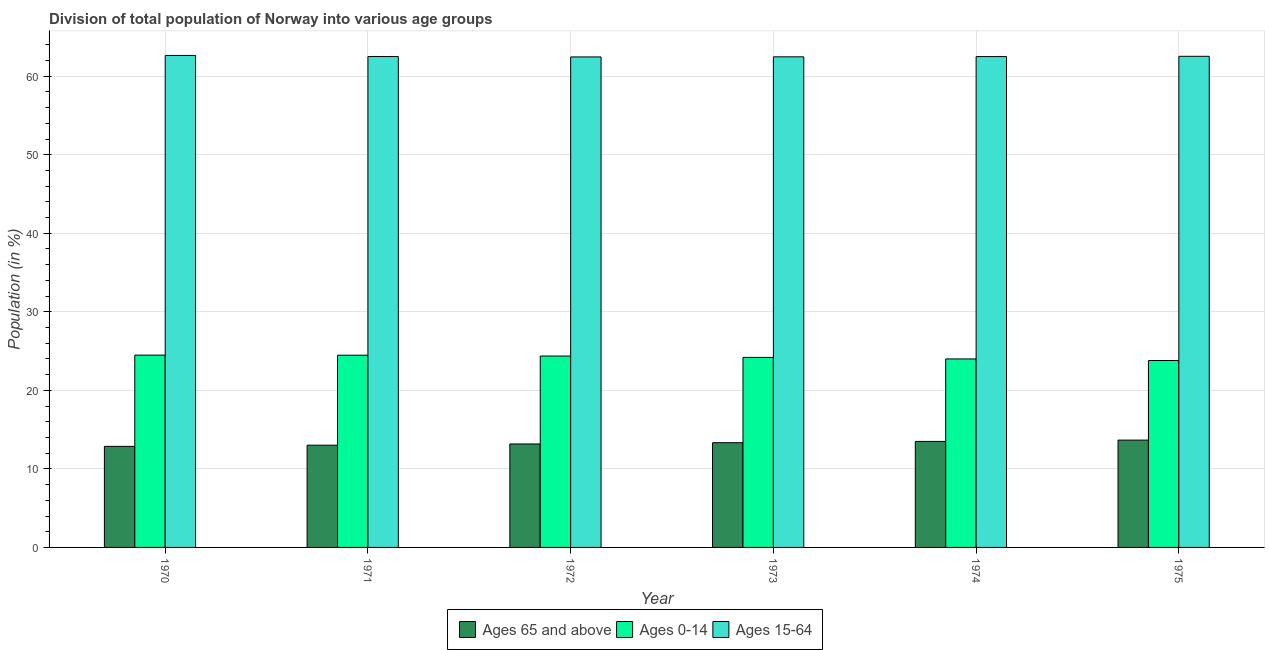How many different coloured bars are there?
Your response must be concise. 3. How many groups of bars are there?
Your answer should be compact. 6. How many bars are there on the 6th tick from the right?
Provide a succinct answer. 3. What is the label of the 6th group of bars from the left?
Provide a succinct answer. 1975. What is the percentage of population within the age-group 15-64 in 1971?
Your answer should be compact. 62.5. Across all years, what is the maximum percentage of population within the age-group 15-64?
Provide a short and direct response. 62.65. Across all years, what is the minimum percentage of population within the age-group 15-64?
Provide a succinct answer. 62.46. In which year was the percentage of population within the age-group 0-14 maximum?
Your response must be concise. 1970. In which year was the percentage of population within the age-group 15-64 minimum?
Provide a succinct answer. 1972. What is the total percentage of population within the age-group 15-64 in the graph?
Provide a succinct answer. 375.11. What is the difference between the percentage of population within the age-group 0-14 in 1974 and that in 1975?
Offer a very short reply. 0.2. What is the difference between the percentage of population within the age-group of 65 and above in 1970 and the percentage of population within the age-group 15-64 in 1971?
Offer a terse response. -0.15. What is the average percentage of population within the age-group 15-64 per year?
Offer a very short reply. 62.52. In the year 1974, what is the difference between the percentage of population within the age-group of 65 and above and percentage of population within the age-group 0-14?
Your answer should be compact. 0. In how many years, is the percentage of population within the age-group 15-64 greater than 20 %?
Provide a succinct answer. 6. What is the ratio of the percentage of population within the age-group 15-64 in 1970 to that in 1972?
Offer a terse response. 1. What is the difference between the highest and the second highest percentage of population within the age-group 0-14?
Provide a short and direct response. 0.01. What is the difference between the highest and the lowest percentage of population within the age-group 15-64?
Ensure brevity in your answer.  0.19. In how many years, is the percentage of population within the age-group of 65 and above greater than the average percentage of population within the age-group of 65 and above taken over all years?
Offer a very short reply. 3. What does the 2nd bar from the left in 1970 represents?
Your answer should be compact. Ages 0-14. What does the 2nd bar from the right in 1975 represents?
Give a very brief answer. Ages 0-14. Is it the case that in every year, the sum of the percentage of population within the age-group of 65 and above and percentage of population within the age-group 0-14 is greater than the percentage of population within the age-group 15-64?
Your response must be concise. No. How many bars are there?
Ensure brevity in your answer.  18. Are all the bars in the graph horizontal?
Provide a short and direct response. No. How many legend labels are there?
Make the answer very short. 3. How are the legend labels stacked?
Give a very brief answer. Horizontal. What is the title of the graph?
Offer a very short reply. Division of total population of Norway into various age groups
. What is the label or title of the X-axis?
Your response must be concise. Year. What is the Population (in %) of Ages 65 and above in 1970?
Give a very brief answer. 12.87. What is the Population (in %) of Ages 0-14 in 1970?
Ensure brevity in your answer.  24.49. What is the Population (in %) in Ages 15-64 in 1970?
Your response must be concise. 62.65. What is the Population (in %) of Ages 65 and above in 1971?
Keep it short and to the point. 13.02. What is the Population (in %) of Ages 0-14 in 1971?
Make the answer very short. 24.48. What is the Population (in %) of Ages 15-64 in 1971?
Give a very brief answer. 62.5. What is the Population (in %) in Ages 65 and above in 1972?
Keep it short and to the point. 13.17. What is the Population (in %) in Ages 0-14 in 1972?
Offer a terse response. 24.37. What is the Population (in %) of Ages 15-64 in 1972?
Provide a short and direct response. 62.46. What is the Population (in %) in Ages 65 and above in 1973?
Give a very brief answer. 13.34. What is the Population (in %) of Ages 0-14 in 1973?
Provide a short and direct response. 24.2. What is the Population (in %) in Ages 15-64 in 1973?
Your response must be concise. 62.47. What is the Population (in %) of Ages 65 and above in 1974?
Provide a short and direct response. 13.5. What is the Population (in %) of Ages 0-14 in 1974?
Provide a short and direct response. 24. What is the Population (in %) of Ages 15-64 in 1974?
Provide a succinct answer. 62.5. What is the Population (in %) in Ages 65 and above in 1975?
Make the answer very short. 13.67. What is the Population (in %) in Ages 0-14 in 1975?
Your answer should be very brief. 23.8. What is the Population (in %) in Ages 15-64 in 1975?
Ensure brevity in your answer.  62.53. Across all years, what is the maximum Population (in %) in Ages 65 and above?
Your answer should be compact. 13.67. Across all years, what is the maximum Population (in %) in Ages 0-14?
Give a very brief answer. 24.49. Across all years, what is the maximum Population (in %) in Ages 15-64?
Ensure brevity in your answer.  62.65. Across all years, what is the minimum Population (in %) in Ages 65 and above?
Ensure brevity in your answer.  12.87. Across all years, what is the minimum Population (in %) of Ages 0-14?
Give a very brief answer. 23.8. Across all years, what is the minimum Population (in %) of Ages 15-64?
Ensure brevity in your answer.  62.46. What is the total Population (in %) of Ages 65 and above in the graph?
Offer a very short reply. 79.56. What is the total Population (in %) of Ages 0-14 in the graph?
Offer a very short reply. 145.33. What is the total Population (in %) of Ages 15-64 in the graph?
Provide a short and direct response. 375.11. What is the difference between the Population (in %) in Ages 65 and above in 1970 and that in 1971?
Offer a terse response. -0.15. What is the difference between the Population (in %) of Ages 0-14 in 1970 and that in 1971?
Ensure brevity in your answer.  0.01. What is the difference between the Population (in %) of Ages 15-64 in 1970 and that in 1971?
Give a very brief answer. 0.14. What is the difference between the Population (in %) in Ages 65 and above in 1970 and that in 1972?
Make the answer very short. -0.31. What is the difference between the Population (in %) in Ages 0-14 in 1970 and that in 1972?
Offer a terse response. 0.12. What is the difference between the Population (in %) in Ages 15-64 in 1970 and that in 1972?
Your answer should be very brief. 0.19. What is the difference between the Population (in %) of Ages 65 and above in 1970 and that in 1973?
Provide a short and direct response. -0.47. What is the difference between the Population (in %) of Ages 0-14 in 1970 and that in 1973?
Keep it short and to the point. 0.29. What is the difference between the Population (in %) in Ages 15-64 in 1970 and that in 1973?
Give a very brief answer. 0.18. What is the difference between the Population (in %) of Ages 65 and above in 1970 and that in 1974?
Your answer should be compact. -0.63. What is the difference between the Population (in %) in Ages 0-14 in 1970 and that in 1974?
Your answer should be very brief. 0.48. What is the difference between the Population (in %) in Ages 15-64 in 1970 and that in 1974?
Provide a succinct answer. 0.15. What is the difference between the Population (in %) in Ages 65 and above in 1970 and that in 1975?
Give a very brief answer. -0.8. What is the difference between the Population (in %) of Ages 0-14 in 1970 and that in 1975?
Your answer should be compact. 0.69. What is the difference between the Population (in %) in Ages 15-64 in 1970 and that in 1975?
Provide a succinct answer. 0.11. What is the difference between the Population (in %) in Ages 65 and above in 1971 and that in 1972?
Offer a very short reply. -0.16. What is the difference between the Population (in %) of Ages 0-14 in 1971 and that in 1972?
Provide a short and direct response. 0.11. What is the difference between the Population (in %) of Ages 15-64 in 1971 and that in 1972?
Your answer should be compact. 0.05. What is the difference between the Population (in %) of Ages 65 and above in 1971 and that in 1973?
Offer a very short reply. -0.32. What is the difference between the Population (in %) in Ages 0-14 in 1971 and that in 1973?
Ensure brevity in your answer.  0.28. What is the difference between the Population (in %) of Ages 15-64 in 1971 and that in 1973?
Offer a very short reply. 0.04. What is the difference between the Population (in %) in Ages 65 and above in 1971 and that in 1974?
Provide a succinct answer. -0.48. What is the difference between the Population (in %) of Ages 0-14 in 1971 and that in 1974?
Your answer should be compact. 0.47. What is the difference between the Population (in %) in Ages 15-64 in 1971 and that in 1974?
Offer a very short reply. 0. What is the difference between the Population (in %) in Ages 65 and above in 1971 and that in 1975?
Offer a terse response. -0.65. What is the difference between the Population (in %) of Ages 0-14 in 1971 and that in 1975?
Your answer should be very brief. 0.68. What is the difference between the Population (in %) of Ages 15-64 in 1971 and that in 1975?
Keep it short and to the point. -0.03. What is the difference between the Population (in %) of Ages 65 and above in 1972 and that in 1973?
Ensure brevity in your answer.  -0.16. What is the difference between the Population (in %) of Ages 0-14 in 1972 and that in 1973?
Make the answer very short. 0.17. What is the difference between the Population (in %) in Ages 15-64 in 1972 and that in 1973?
Provide a succinct answer. -0.01. What is the difference between the Population (in %) of Ages 65 and above in 1972 and that in 1974?
Ensure brevity in your answer.  -0.32. What is the difference between the Population (in %) in Ages 0-14 in 1972 and that in 1974?
Make the answer very short. 0.37. What is the difference between the Population (in %) in Ages 15-64 in 1972 and that in 1974?
Ensure brevity in your answer.  -0.04. What is the difference between the Population (in %) of Ages 65 and above in 1972 and that in 1975?
Offer a very short reply. -0.49. What is the difference between the Population (in %) of Ages 0-14 in 1972 and that in 1975?
Provide a short and direct response. 0.57. What is the difference between the Population (in %) of Ages 15-64 in 1972 and that in 1975?
Provide a short and direct response. -0.08. What is the difference between the Population (in %) in Ages 65 and above in 1973 and that in 1974?
Provide a succinct answer. -0.16. What is the difference between the Population (in %) of Ages 0-14 in 1973 and that in 1974?
Give a very brief answer. 0.19. What is the difference between the Population (in %) in Ages 15-64 in 1973 and that in 1974?
Ensure brevity in your answer.  -0.03. What is the difference between the Population (in %) in Ages 65 and above in 1973 and that in 1975?
Give a very brief answer. -0.33. What is the difference between the Population (in %) in Ages 0-14 in 1973 and that in 1975?
Give a very brief answer. 0.4. What is the difference between the Population (in %) in Ages 15-64 in 1973 and that in 1975?
Keep it short and to the point. -0.07. What is the difference between the Population (in %) in Ages 65 and above in 1974 and that in 1975?
Your response must be concise. -0.17. What is the difference between the Population (in %) of Ages 0-14 in 1974 and that in 1975?
Make the answer very short. 0.2. What is the difference between the Population (in %) in Ages 15-64 in 1974 and that in 1975?
Your answer should be compact. -0.04. What is the difference between the Population (in %) in Ages 65 and above in 1970 and the Population (in %) in Ages 0-14 in 1971?
Your answer should be very brief. -11.61. What is the difference between the Population (in %) of Ages 65 and above in 1970 and the Population (in %) of Ages 15-64 in 1971?
Provide a succinct answer. -49.64. What is the difference between the Population (in %) of Ages 0-14 in 1970 and the Population (in %) of Ages 15-64 in 1971?
Ensure brevity in your answer.  -38.02. What is the difference between the Population (in %) of Ages 65 and above in 1970 and the Population (in %) of Ages 0-14 in 1972?
Your answer should be compact. -11.5. What is the difference between the Population (in %) in Ages 65 and above in 1970 and the Population (in %) in Ages 15-64 in 1972?
Offer a very short reply. -49.59. What is the difference between the Population (in %) in Ages 0-14 in 1970 and the Population (in %) in Ages 15-64 in 1972?
Give a very brief answer. -37.97. What is the difference between the Population (in %) in Ages 65 and above in 1970 and the Population (in %) in Ages 0-14 in 1973?
Your answer should be compact. -11.33. What is the difference between the Population (in %) in Ages 65 and above in 1970 and the Population (in %) in Ages 15-64 in 1973?
Your answer should be very brief. -49.6. What is the difference between the Population (in %) of Ages 0-14 in 1970 and the Population (in %) of Ages 15-64 in 1973?
Make the answer very short. -37.98. What is the difference between the Population (in %) of Ages 65 and above in 1970 and the Population (in %) of Ages 0-14 in 1974?
Offer a very short reply. -11.13. What is the difference between the Population (in %) in Ages 65 and above in 1970 and the Population (in %) in Ages 15-64 in 1974?
Provide a short and direct response. -49.63. What is the difference between the Population (in %) of Ages 0-14 in 1970 and the Population (in %) of Ages 15-64 in 1974?
Make the answer very short. -38.01. What is the difference between the Population (in %) of Ages 65 and above in 1970 and the Population (in %) of Ages 0-14 in 1975?
Your answer should be compact. -10.93. What is the difference between the Population (in %) of Ages 65 and above in 1970 and the Population (in %) of Ages 15-64 in 1975?
Give a very brief answer. -49.67. What is the difference between the Population (in %) in Ages 0-14 in 1970 and the Population (in %) in Ages 15-64 in 1975?
Ensure brevity in your answer.  -38.05. What is the difference between the Population (in %) of Ages 65 and above in 1971 and the Population (in %) of Ages 0-14 in 1972?
Make the answer very short. -11.35. What is the difference between the Population (in %) of Ages 65 and above in 1971 and the Population (in %) of Ages 15-64 in 1972?
Provide a succinct answer. -49.44. What is the difference between the Population (in %) in Ages 0-14 in 1971 and the Population (in %) in Ages 15-64 in 1972?
Keep it short and to the point. -37.98. What is the difference between the Population (in %) in Ages 65 and above in 1971 and the Population (in %) in Ages 0-14 in 1973?
Give a very brief answer. -11.18. What is the difference between the Population (in %) in Ages 65 and above in 1971 and the Population (in %) in Ages 15-64 in 1973?
Offer a terse response. -49.45. What is the difference between the Population (in %) in Ages 0-14 in 1971 and the Population (in %) in Ages 15-64 in 1973?
Provide a short and direct response. -37.99. What is the difference between the Population (in %) in Ages 65 and above in 1971 and the Population (in %) in Ages 0-14 in 1974?
Provide a short and direct response. -10.98. What is the difference between the Population (in %) of Ages 65 and above in 1971 and the Population (in %) of Ages 15-64 in 1974?
Give a very brief answer. -49.48. What is the difference between the Population (in %) of Ages 0-14 in 1971 and the Population (in %) of Ages 15-64 in 1974?
Your response must be concise. -38.02. What is the difference between the Population (in %) of Ages 65 and above in 1971 and the Population (in %) of Ages 0-14 in 1975?
Your answer should be very brief. -10.78. What is the difference between the Population (in %) in Ages 65 and above in 1971 and the Population (in %) in Ages 15-64 in 1975?
Offer a terse response. -49.52. What is the difference between the Population (in %) in Ages 0-14 in 1971 and the Population (in %) in Ages 15-64 in 1975?
Ensure brevity in your answer.  -38.06. What is the difference between the Population (in %) of Ages 65 and above in 1972 and the Population (in %) of Ages 0-14 in 1973?
Your answer should be very brief. -11.02. What is the difference between the Population (in %) of Ages 65 and above in 1972 and the Population (in %) of Ages 15-64 in 1973?
Your response must be concise. -49.29. What is the difference between the Population (in %) in Ages 0-14 in 1972 and the Population (in %) in Ages 15-64 in 1973?
Offer a terse response. -38.1. What is the difference between the Population (in %) in Ages 65 and above in 1972 and the Population (in %) in Ages 0-14 in 1974?
Give a very brief answer. -10.83. What is the difference between the Population (in %) in Ages 65 and above in 1972 and the Population (in %) in Ages 15-64 in 1974?
Make the answer very short. -49.32. What is the difference between the Population (in %) in Ages 0-14 in 1972 and the Population (in %) in Ages 15-64 in 1974?
Your answer should be compact. -38.13. What is the difference between the Population (in %) of Ages 65 and above in 1972 and the Population (in %) of Ages 0-14 in 1975?
Provide a succinct answer. -10.63. What is the difference between the Population (in %) in Ages 65 and above in 1972 and the Population (in %) in Ages 15-64 in 1975?
Your answer should be compact. -49.36. What is the difference between the Population (in %) of Ages 0-14 in 1972 and the Population (in %) of Ages 15-64 in 1975?
Offer a very short reply. -38.16. What is the difference between the Population (in %) of Ages 65 and above in 1973 and the Population (in %) of Ages 0-14 in 1974?
Offer a very short reply. -10.67. What is the difference between the Population (in %) of Ages 65 and above in 1973 and the Population (in %) of Ages 15-64 in 1974?
Keep it short and to the point. -49.16. What is the difference between the Population (in %) in Ages 0-14 in 1973 and the Population (in %) in Ages 15-64 in 1974?
Offer a terse response. -38.3. What is the difference between the Population (in %) in Ages 65 and above in 1973 and the Population (in %) in Ages 0-14 in 1975?
Offer a very short reply. -10.46. What is the difference between the Population (in %) of Ages 65 and above in 1973 and the Population (in %) of Ages 15-64 in 1975?
Provide a succinct answer. -49.2. What is the difference between the Population (in %) in Ages 0-14 in 1973 and the Population (in %) in Ages 15-64 in 1975?
Make the answer very short. -38.34. What is the difference between the Population (in %) in Ages 65 and above in 1974 and the Population (in %) in Ages 0-14 in 1975?
Provide a short and direct response. -10.3. What is the difference between the Population (in %) in Ages 65 and above in 1974 and the Population (in %) in Ages 15-64 in 1975?
Provide a short and direct response. -49.04. What is the difference between the Population (in %) in Ages 0-14 in 1974 and the Population (in %) in Ages 15-64 in 1975?
Your response must be concise. -38.53. What is the average Population (in %) in Ages 65 and above per year?
Keep it short and to the point. 13.26. What is the average Population (in %) in Ages 0-14 per year?
Your response must be concise. 24.22. What is the average Population (in %) in Ages 15-64 per year?
Keep it short and to the point. 62.52. In the year 1970, what is the difference between the Population (in %) in Ages 65 and above and Population (in %) in Ages 0-14?
Give a very brief answer. -11.62. In the year 1970, what is the difference between the Population (in %) in Ages 65 and above and Population (in %) in Ages 15-64?
Your response must be concise. -49.78. In the year 1970, what is the difference between the Population (in %) of Ages 0-14 and Population (in %) of Ages 15-64?
Keep it short and to the point. -38.16. In the year 1971, what is the difference between the Population (in %) of Ages 65 and above and Population (in %) of Ages 0-14?
Offer a very short reply. -11.46. In the year 1971, what is the difference between the Population (in %) of Ages 65 and above and Population (in %) of Ages 15-64?
Provide a succinct answer. -49.49. In the year 1971, what is the difference between the Population (in %) of Ages 0-14 and Population (in %) of Ages 15-64?
Your response must be concise. -38.03. In the year 1972, what is the difference between the Population (in %) in Ages 65 and above and Population (in %) in Ages 0-14?
Give a very brief answer. -11.19. In the year 1972, what is the difference between the Population (in %) in Ages 65 and above and Population (in %) in Ages 15-64?
Ensure brevity in your answer.  -49.28. In the year 1972, what is the difference between the Population (in %) of Ages 0-14 and Population (in %) of Ages 15-64?
Provide a succinct answer. -38.09. In the year 1973, what is the difference between the Population (in %) of Ages 65 and above and Population (in %) of Ages 0-14?
Make the answer very short. -10.86. In the year 1973, what is the difference between the Population (in %) in Ages 65 and above and Population (in %) in Ages 15-64?
Provide a succinct answer. -49.13. In the year 1973, what is the difference between the Population (in %) in Ages 0-14 and Population (in %) in Ages 15-64?
Make the answer very short. -38.27. In the year 1974, what is the difference between the Population (in %) in Ages 65 and above and Population (in %) in Ages 0-14?
Ensure brevity in your answer.  -10.5. In the year 1974, what is the difference between the Population (in %) of Ages 65 and above and Population (in %) of Ages 15-64?
Offer a terse response. -49. In the year 1974, what is the difference between the Population (in %) in Ages 0-14 and Population (in %) in Ages 15-64?
Provide a succinct answer. -38.5. In the year 1975, what is the difference between the Population (in %) in Ages 65 and above and Population (in %) in Ages 0-14?
Offer a terse response. -10.13. In the year 1975, what is the difference between the Population (in %) of Ages 65 and above and Population (in %) of Ages 15-64?
Your response must be concise. -48.87. In the year 1975, what is the difference between the Population (in %) of Ages 0-14 and Population (in %) of Ages 15-64?
Your answer should be compact. -38.73. What is the ratio of the Population (in %) in Ages 65 and above in 1970 to that in 1971?
Make the answer very short. 0.99. What is the ratio of the Population (in %) of Ages 0-14 in 1970 to that in 1971?
Your response must be concise. 1. What is the ratio of the Population (in %) in Ages 65 and above in 1970 to that in 1972?
Provide a succinct answer. 0.98. What is the ratio of the Population (in %) of Ages 15-64 in 1970 to that in 1972?
Provide a short and direct response. 1. What is the ratio of the Population (in %) of Ages 65 and above in 1970 to that in 1973?
Offer a terse response. 0.96. What is the ratio of the Population (in %) of Ages 0-14 in 1970 to that in 1973?
Provide a short and direct response. 1.01. What is the ratio of the Population (in %) of Ages 15-64 in 1970 to that in 1973?
Give a very brief answer. 1. What is the ratio of the Population (in %) of Ages 65 and above in 1970 to that in 1974?
Give a very brief answer. 0.95. What is the ratio of the Population (in %) of Ages 0-14 in 1970 to that in 1974?
Offer a very short reply. 1.02. What is the ratio of the Population (in %) in Ages 15-64 in 1970 to that in 1974?
Provide a succinct answer. 1. What is the ratio of the Population (in %) in Ages 65 and above in 1970 to that in 1975?
Make the answer very short. 0.94. What is the ratio of the Population (in %) of Ages 0-14 in 1970 to that in 1975?
Your answer should be compact. 1.03. What is the ratio of the Population (in %) of Ages 65 and above in 1971 to that in 1972?
Your answer should be compact. 0.99. What is the ratio of the Population (in %) in Ages 0-14 in 1971 to that in 1972?
Provide a succinct answer. 1. What is the ratio of the Population (in %) in Ages 15-64 in 1971 to that in 1972?
Offer a very short reply. 1. What is the ratio of the Population (in %) of Ages 65 and above in 1971 to that in 1973?
Your answer should be very brief. 0.98. What is the ratio of the Population (in %) of Ages 0-14 in 1971 to that in 1973?
Your response must be concise. 1.01. What is the ratio of the Population (in %) in Ages 15-64 in 1971 to that in 1973?
Your response must be concise. 1. What is the ratio of the Population (in %) of Ages 65 and above in 1971 to that in 1974?
Your answer should be very brief. 0.96. What is the ratio of the Population (in %) of Ages 0-14 in 1971 to that in 1974?
Offer a terse response. 1.02. What is the ratio of the Population (in %) of Ages 15-64 in 1971 to that in 1974?
Make the answer very short. 1. What is the ratio of the Population (in %) of Ages 65 and above in 1971 to that in 1975?
Ensure brevity in your answer.  0.95. What is the ratio of the Population (in %) in Ages 0-14 in 1971 to that in 1975?
Give a very brief answer. 1.03. What is the ratio of the Population (in %) of Ages 15-64 in 1971 to that in 1975?
Make the answer very short. 1. What is the ratio of the Population (in %) in Ages 65 and above in 1972 to that in 1974?
Offer a very short reply. 0.98. What is the ratio of the Population (in %) of Ages 0-14 in 1972 to that in 1974?
Your answer should be compact. 1.02. What is the ratio of the Population (in %) in Ages 15-64 in 1972 to that in 1974?
Ensure brevity in your answer.  1. What is the ratio of the Population (in %) of Ages 65 and above in 1972 to that in 1975?
Make the answer very short. 0.96. What is the ratio of the Population (in %) of Ages 0-14 in 1972 to that in 1975?
Provide a short and direct response. 1.02. What is the ratio of the Population (in %) of Ages 65 and above in 1973 to that in 1974?
Offer a very short reply. 0.99. What is the ratio of the Population (in %) in Ages 0-14 in 1973 to that in 1974?
Keep it short and to the point. 1.01. What is the ratio of the Population (in %) in Ages 15-64 in 1973 to that in 1974?
Your response must be concise. 1. What is the ratio of the Population (in %) in Ages 65 and above in 1973 to that in 1975?
Keep it short and to the point. 0.98. What is the ratio of the Population (in %) of Ages 0-14 in 1973 to that in 1975?
Your response must be concise. 1.02. What is the ratio of the Population (in %) in Ages 0-14 in 1974 to that in 1975?
Offer a terse response. 1.01. What is the ratio of the Population (in %) in Ages 15-64 in 1974 to that in 1975?
Give a very brief answer. 1. What is the difference between the highest and the second highest Population (in %) in Ages 65 and above?
Your answer should be very brief. 0.17. What is the difference between the highest and the second highest Population (in %) in Ages 0-14?
Give a very brief answer. 0.01. What is the difference between the highest and the second highest Population (in %) in Ages 15-64?
Provide a succinct answer. 0.11. What is the difference between the highest and the lowest Population (in %) of Ages 65 and above?
Your answer should be very brief. 0.8. What is the difference between the highest and the lowest Population (in %) in Ages 0-14?
Offer a terse response. 0.69. What is the difference between the highest and the lowest Population (in %) of Ages 15-64?
Offer a very short reply. 0.19. 